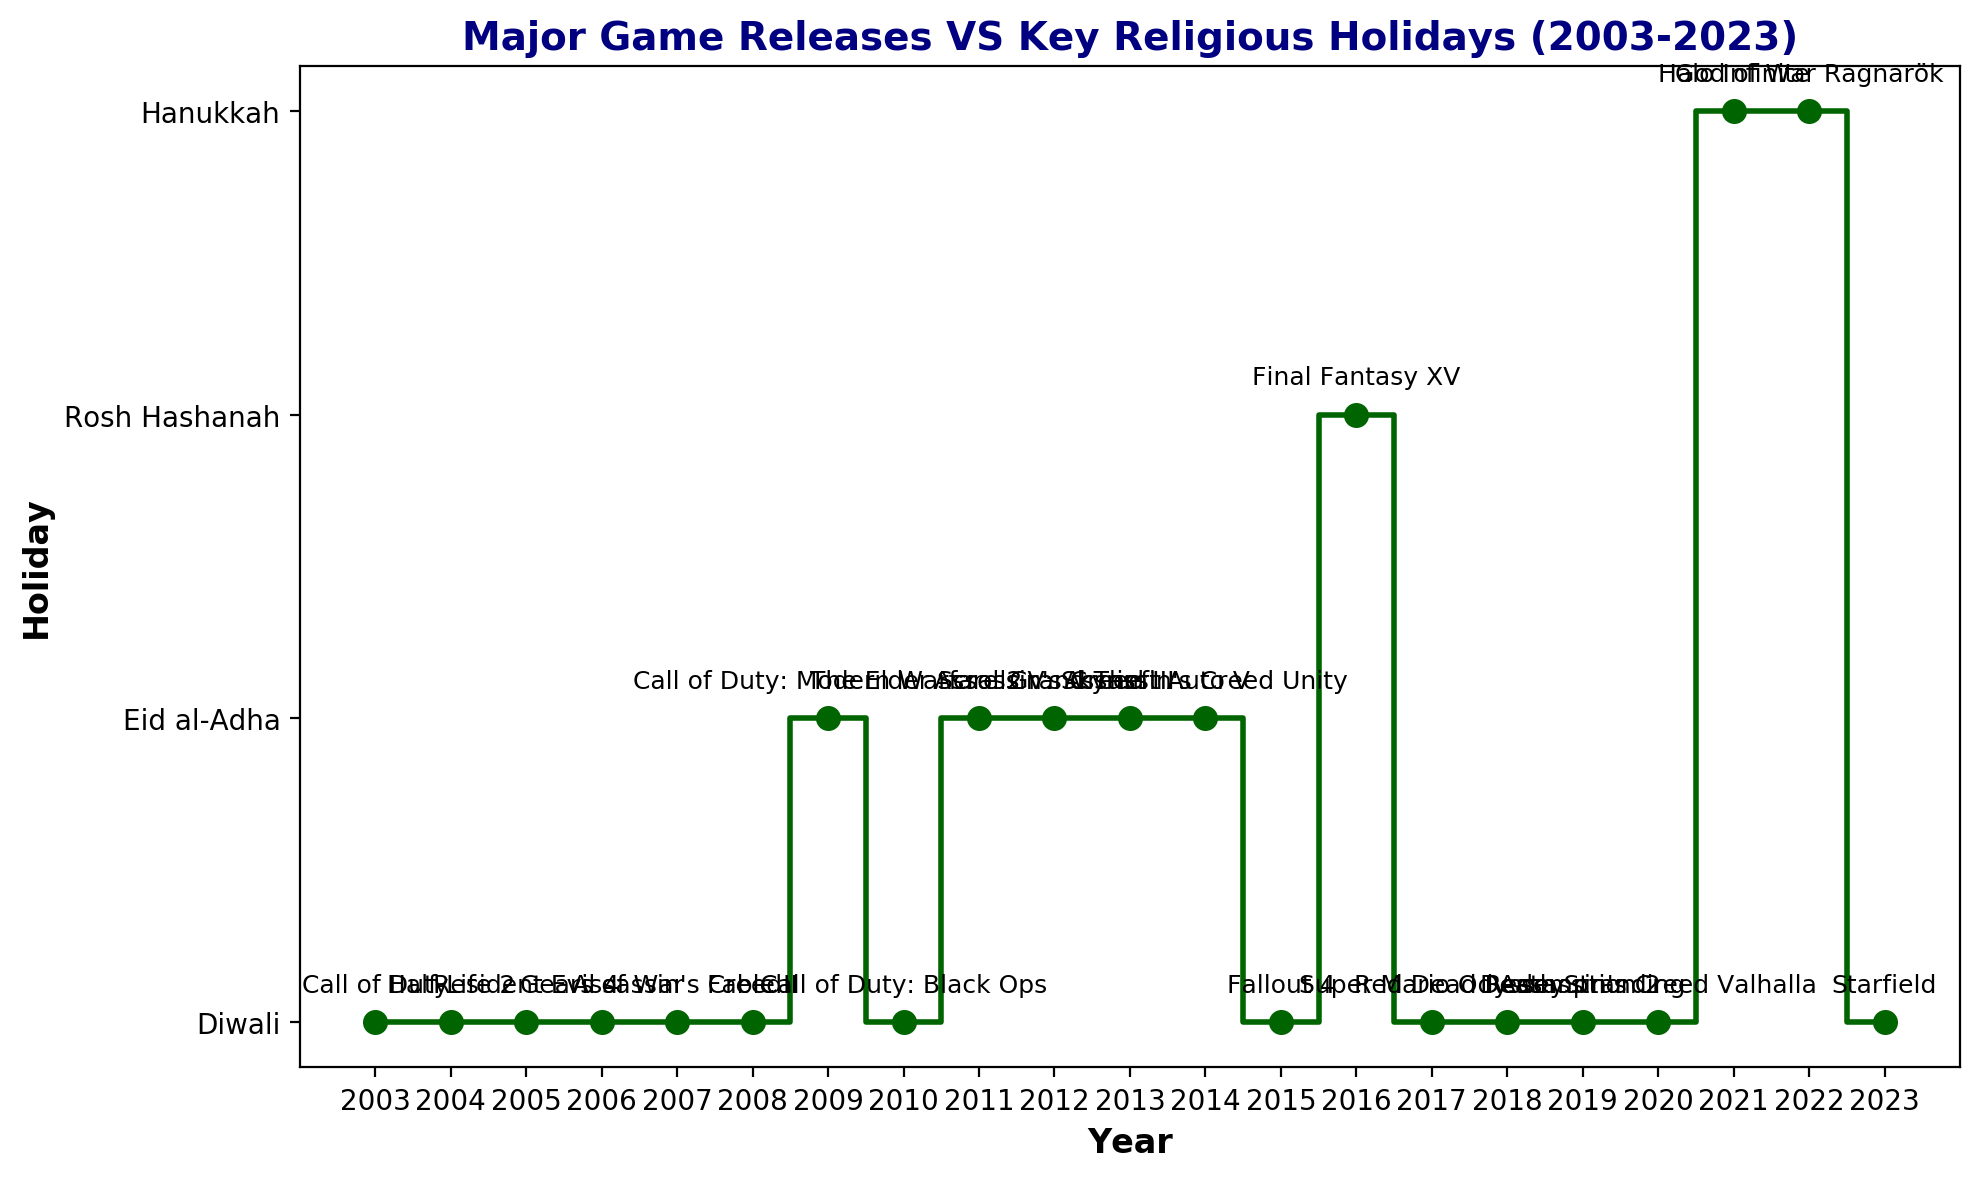What is the first game listed in the plot? The first game listed on the plot is the one appearing at the earliest point on the x-axis. By checking the x-axis, the first year with a marked release is 2003. The game event labeled in 2003 is "Call of Duty".
Answer: Call of Duty Which holiday has the most number of game releases associated with it? Count the frequency of each holiday label on the y-axis. Diwali appears most frequently on the y-axis.
Answer: Diwali In which year was "The Elder Scrolls V: Skyrim" released? Identify the label "The Elder Scrolls V: Skyrim" on the plot and trace it along the x-axis. The game is located at the year 2011.
Answer: 2011 Which game was released closest to Hanukkah? Find the markers labeled with Hanukkah on the y-axis. "Halo Infinite" and "God of War Ragnarök" are both marked on the plot.
Answer: Halo Infinite and God of War Ragnarök How many game releases coincide with Eid al-Adha? Count every instance where events correspond to the y-value of Eid al-Adha. There are five such instances on the plot.
Answer: 5 What is the difference in release years between "Final Fantasy XV" and "Super Mario Odyssey"? Locate the year of release for both "Final Fantasy XV" (2016) and "Super Mario Odyssey" (2017). Then calculate the difference: 2017 - 2016 = 1 year.
Answer: 1 year Were more games released during Diwali or Eid al-Adha over the last 20 years? Count occurrences of game releases during Diwali and Eid al-Adha. Diwali has more releases compared to Eid al-Adha.
Answer: Diwali Which game releases happened in back-to-back years (consecutively) around Diwali? Look for consecutive years on the x-axis where the y-axis value is Diwali. Games released in 2019 and 2020 (Death Stranding and Assassin's Creed Valhalla) fulfill this condition.
Answer: Death Stranding and Assassin's Creed Valhalla How many games were released on religious holidays that are not Diwali? Identify the total number of markers on the y-axis for holidays other than Diwali. Sum these markers: Eid al-Adha, Rosh Hashanah, and Hanukkah. There are two releases each for Hanukkah and five for Eid al-Adha plus one for Rosh Hashanah, totaling 8 releases.
Answer: 8 Which year featured the release of both "Half-Life 2" and a significant game during Diwali? Locate the year for "Half-Life 2" and check if the holiday is Diwali. "Half-Life 2" was released in 2004 during Diwali.
Answer: 2004 